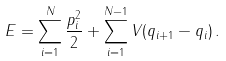Convert formula to latex. <formula><loc_0><loc_0><loc_500><loc_500>E = \sum _ { i = 1 } ^ { N } \frac { p _ { i } ^ { 2 } } { 2 } + \sum _ { i = 1 } ^ { N - 1 } V ( q _ { i + 1 } - q _ { i } ) \, .</formula> 